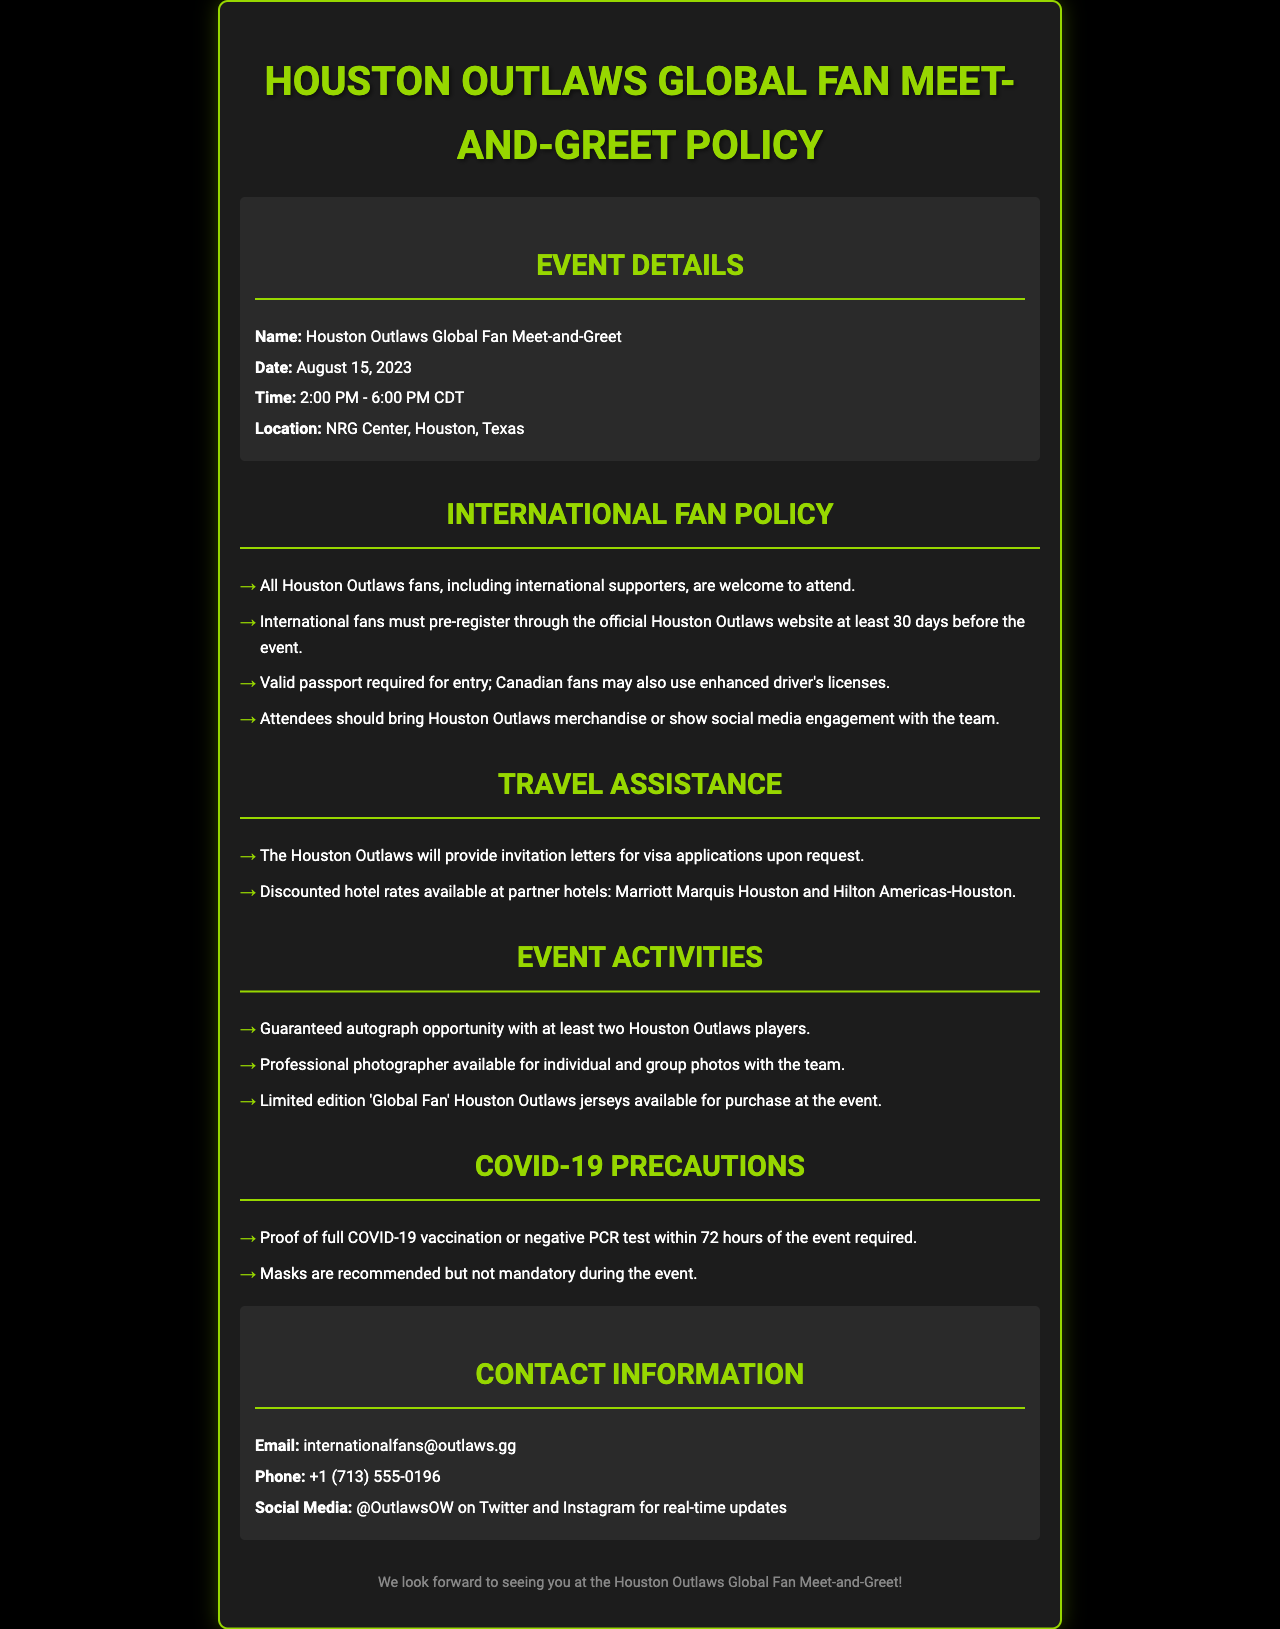What is the name of the event? The name of the event is stated in the "Event Details" section.
Answer: Houston Outlaws Global Fan Meet-and-Greet What is the date of the event? The date of the event is listed under the "Event Details" section.
Answer: August 15, 2023 What is the time of the event? The time is provided in the "Event Details" section.
Answer: 2:00 PM - 6:00 PM CDT Do international fans need to pre-register? This requirement is specified in the "International Fan Policy."
Answer: Yes What documents are required for entry? The required documents are listed in the "International Fan Policy."
Answer: Valid passport What does the Houston Outlaws provide for visa applications? The support provided is mentioned in the "Travel Assistance" section.
Answer: Invitation letters What will attendees receive at the event? The opportunities for attendees are detailed in the "Event Activities" section.
Answer: Autograph opportunity What COVID-19 precautions are required? The precautions required are outlined in the "COVID-19 Precautions" section.
Answer: Proof of full COVID-19 vaccination Who can be contacted for more information? The contact information is provided in the "Contact Information" section.
Answer: internationalfans@outlaws.gg 